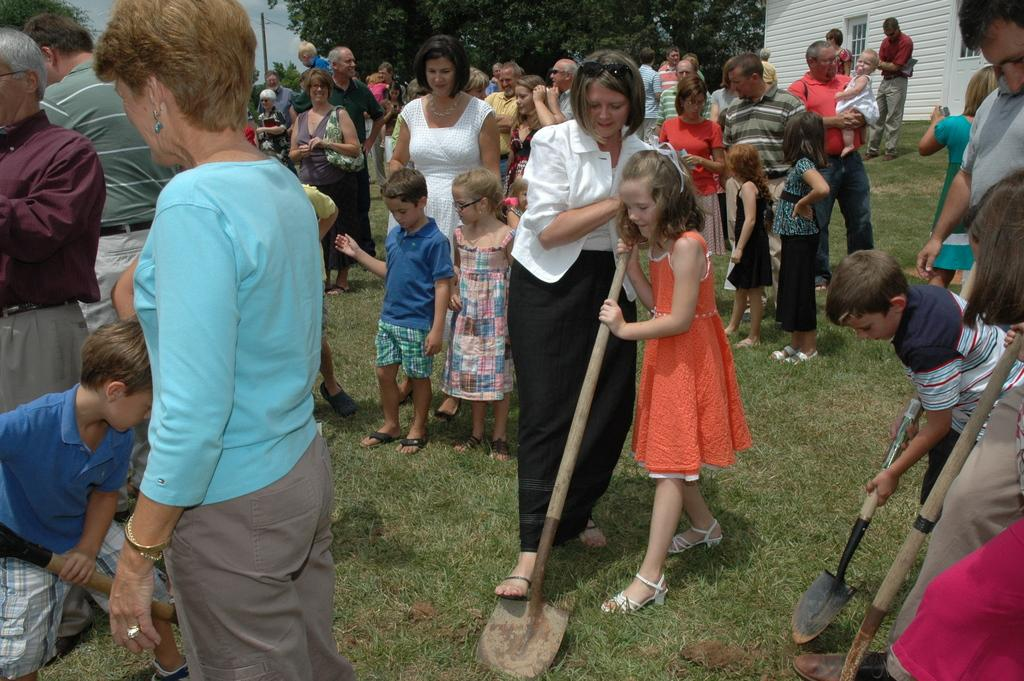How many people are in the image? There is a group of people in the image, but the exact number cannot be determined from the provided facts. What are some people holding in the image? Some people are holding something, but the specific objects cannot be identified from the provided facts. What can be seen in the background of the image? There is a building, glass windows, and trees visible in the background. What is the color of the sky in the image? The sky is blue and white in color. Where is the amusement machine located in the image? There is no amusement machine present in the image. Can you see a tiger in the image? There is no tiger present in the image. 